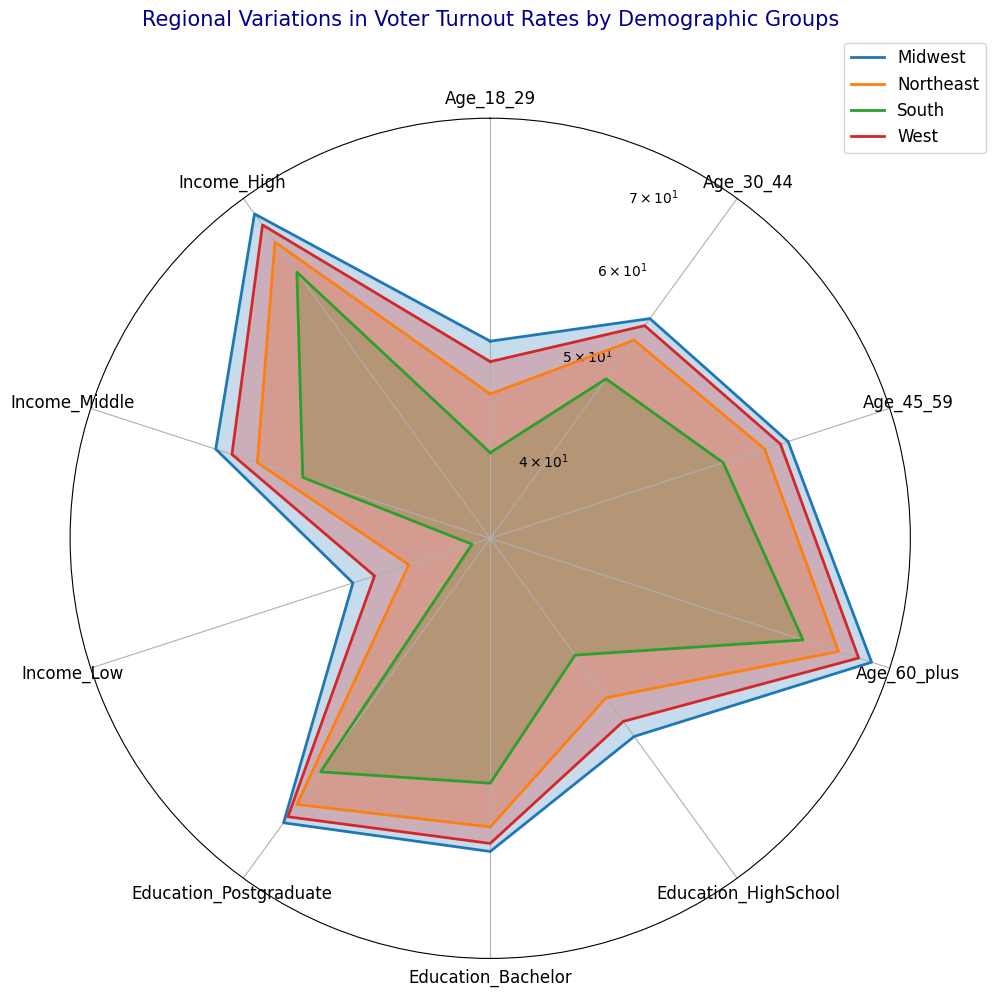Which region has the highest voter turnout rate for the 60+ age group? To identify the region with the highest turnout rate for the 60+ age group, look at the values around the "Age_60_plus" category and compare their heights. The Midwest has the highest value.
Answer: Midwest Which region shows the lowest voter turnout rate for people with a high school education? To find the lowest turnout rate for those with a high school education, refer to the values around the "Education_HighSchool" category. The South has the lowest value.
Answer: South What's the average voter turnout rate for the Northeast across all demographic categories? To calculate the average for the Northeast, sum up the values for all categories and divide by the number of categories: (45+55+60+70+50+60+65+40+55+70 + 46+56+61+71+51+61+66+41+56+71 + 47+57+62+72+52+62+67+42+57+72) ÷ 30 ≈ 57.4.
Answer: 57.4 How does the voter turnout rate for people aged 18-29 in the South compare to the voter turnout rate for people aged 45-59 in the same region? Compare the values for the "Age_18_29" and "Age_45_59" categories in the South. The 18-29 age group has a turnout rate of 40, 41, and 42 while the 45-59 age group has 55, 56, and 57.
Answer: The 45-59 age group has a higher turnout rate Which demographic group shows the most variation in voter turnout rates across all regions? To determine which group has the most variation, look at how much the values differ across regions. The "Age_60_plus" category shows significant variation from 65 to 77.
Answer: Age 60+ Is there a trend in voter turnout rates for the Midwest among different income levels? Check the values for "Income_Low," "Income_Middle," and "Income_High" in the Midwest. The voter turnout rates are 45, 60, and 75, respectively, and show an increasing trend with higher income.
Answer: Increasing trend with higher income Is the turnout rate for postgraduates higher in the West compared to the South? Compare the turnout rates for the "Education_Postgraduate" category in the West and South. The West has 67, 68, and 69 while the South has 60, 61, and 62.
Answer: Yes, the turnout is higher in the West Which region demonstrates the least variation in voter turnout rates across all demographic groups? Assess the range of values in each region. The Northeast shows the least variation with values relatively close to each other.
Answer: Northeast What is the difference in voter turnout rates between the highest and lowest turnout regions for the Income_High group? Identify the highest and lowest values for the "Income_High" category. The Midwest has the highest (75) and the South has the lowest (65). The difference is 75 - 65 = 10.
Answer: 10 How do voter turnout rates for the 30-44 age group vary across regions? Compare the "Age_30_44" category values for each region. The values range from 50 in the South to 60 in the Midwest.
Answer: Range is 50 to 60 